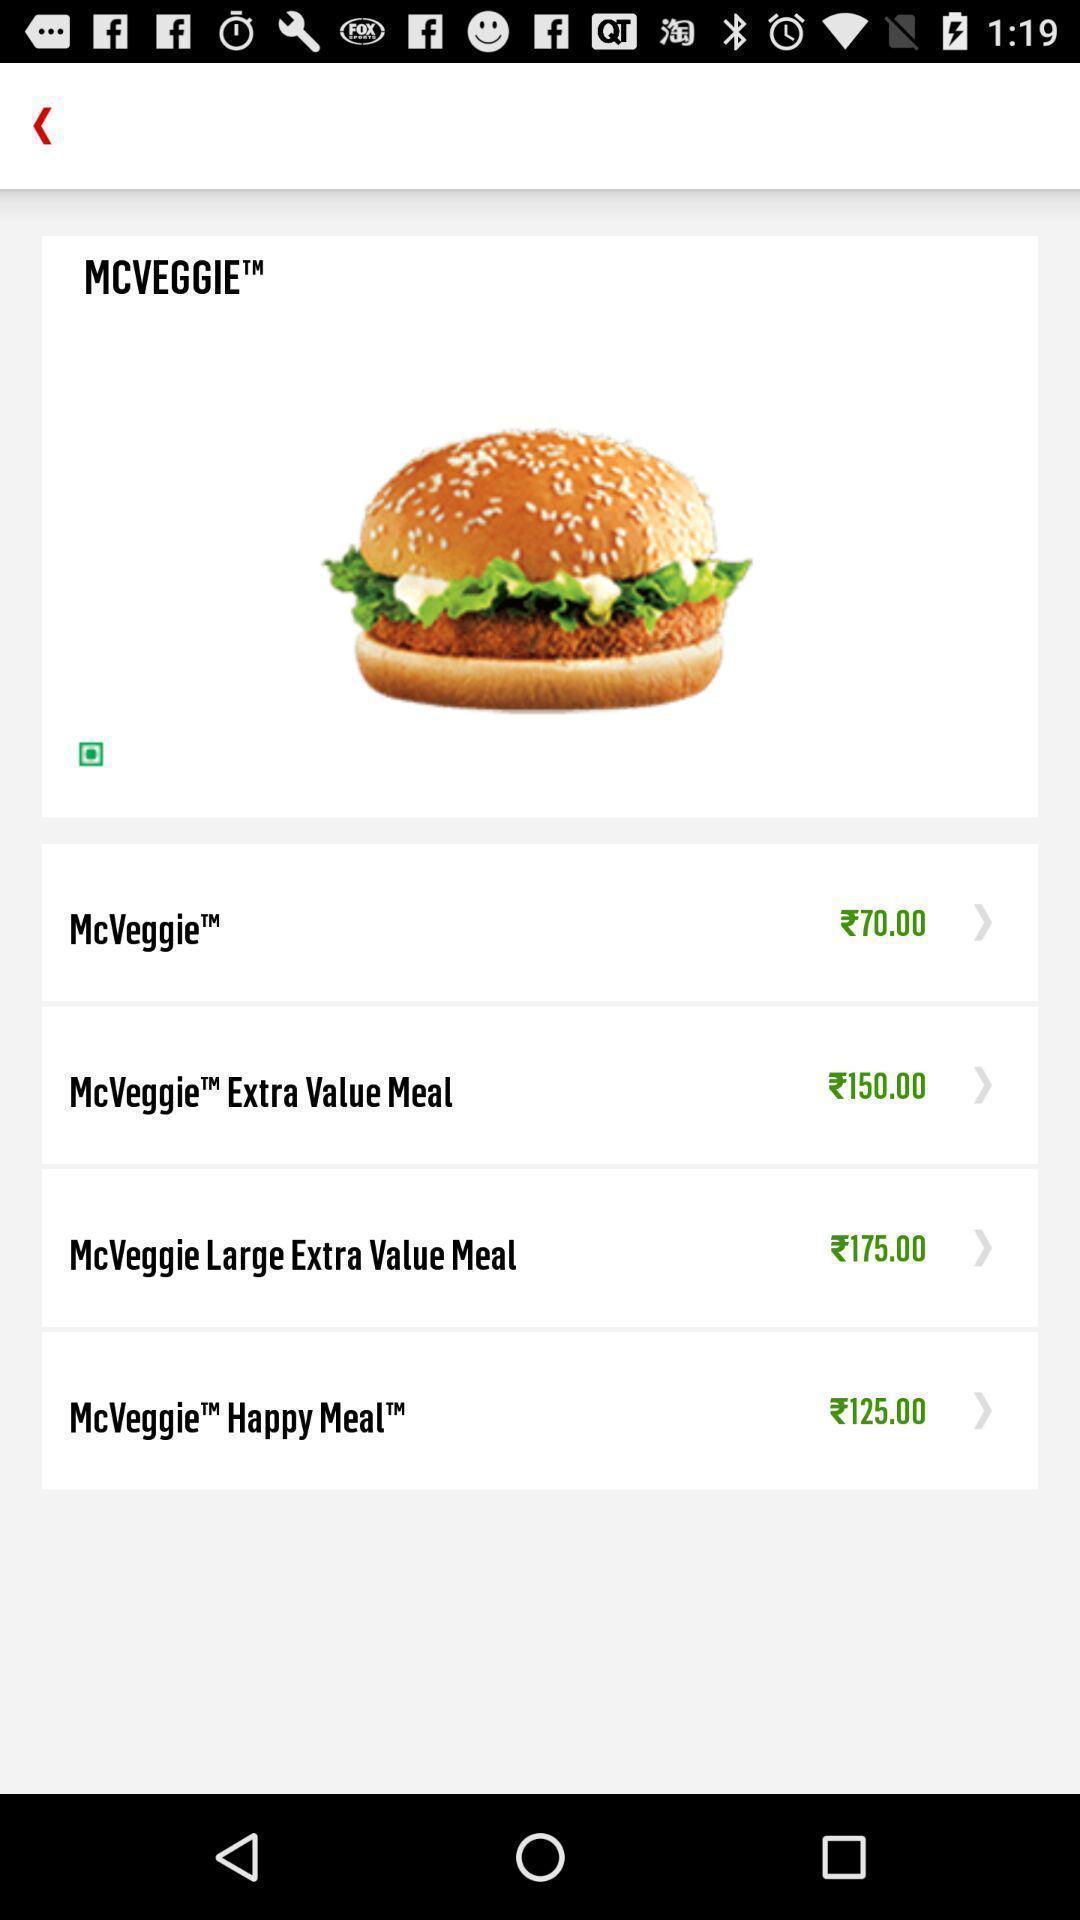Give me a narrative description of this picture. Screen displaying a food application. 